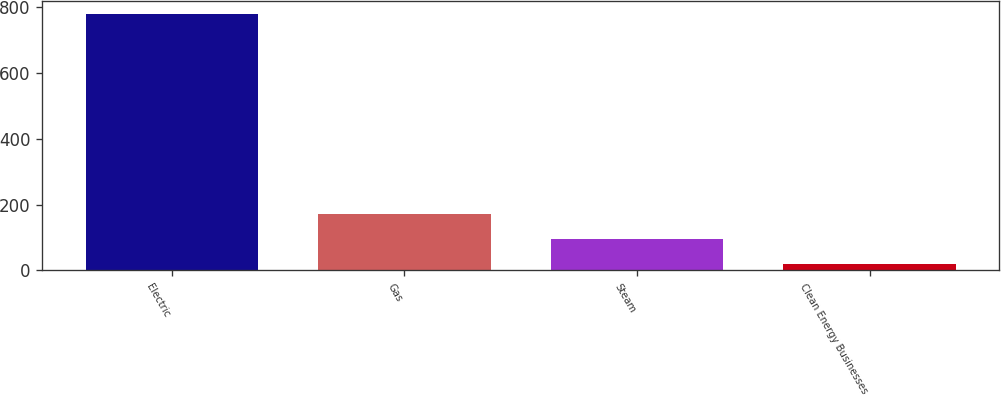<chart> <loc_0><loc_0><loc_500><loc_500><bar_chart><fcel>Electric<fcel>Gas<fcel>Steam<fcel>Clean Energy Businesses<nl><fcel>781<fcel>171.4<fcel>95.2<fcel>19<nl></chart> 